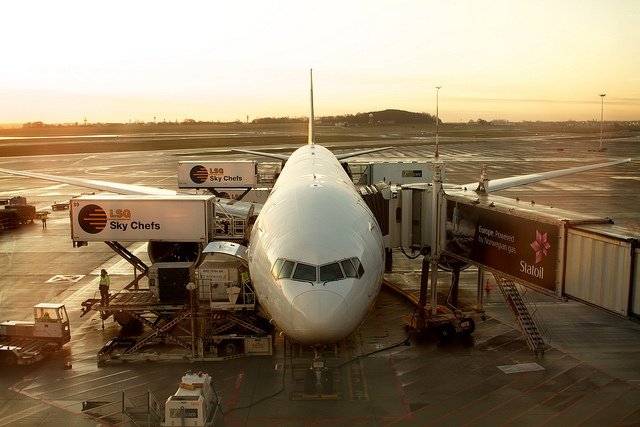Describe the objects in this image and their specific colors. I can see airplane in white, darkgray, gray, tan, and beige tones, truck in white, maroon, and brown tones, truck in white, gray, and black tones, people in white, maroon, and olive tones, and people in white, maroon, and olive tones in this image. 